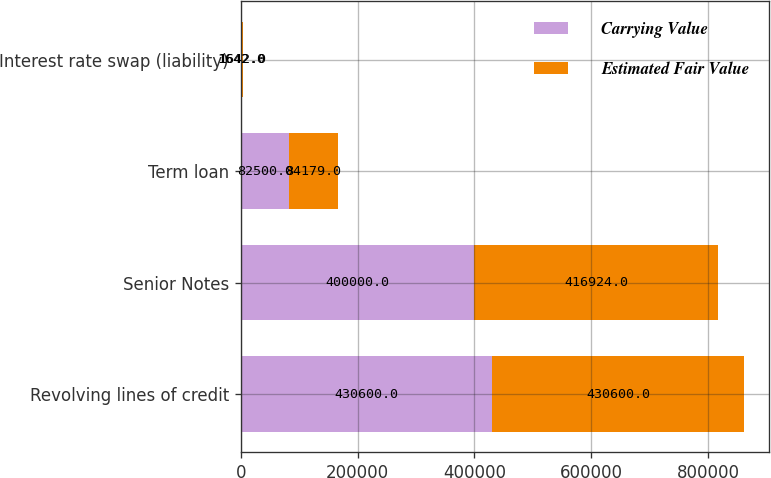Convert chart. <chart><loc_0><loc_0><loc_500><loc_500><stacked_bar_chart><ecel><fcel>Revolving lines of credit<fcel>Senior Notes<fcel>Term loan<fcel>Interest rate swap (liability)<nl><fcel>Carrying Value<fcel>430600<fcel>400000<fcel>82500<fcel>1642<nl><fcel>Estimated Fair Value<fcel>430600<fcel>416924<fcel>84179<fcel>1642<nl></chart> 